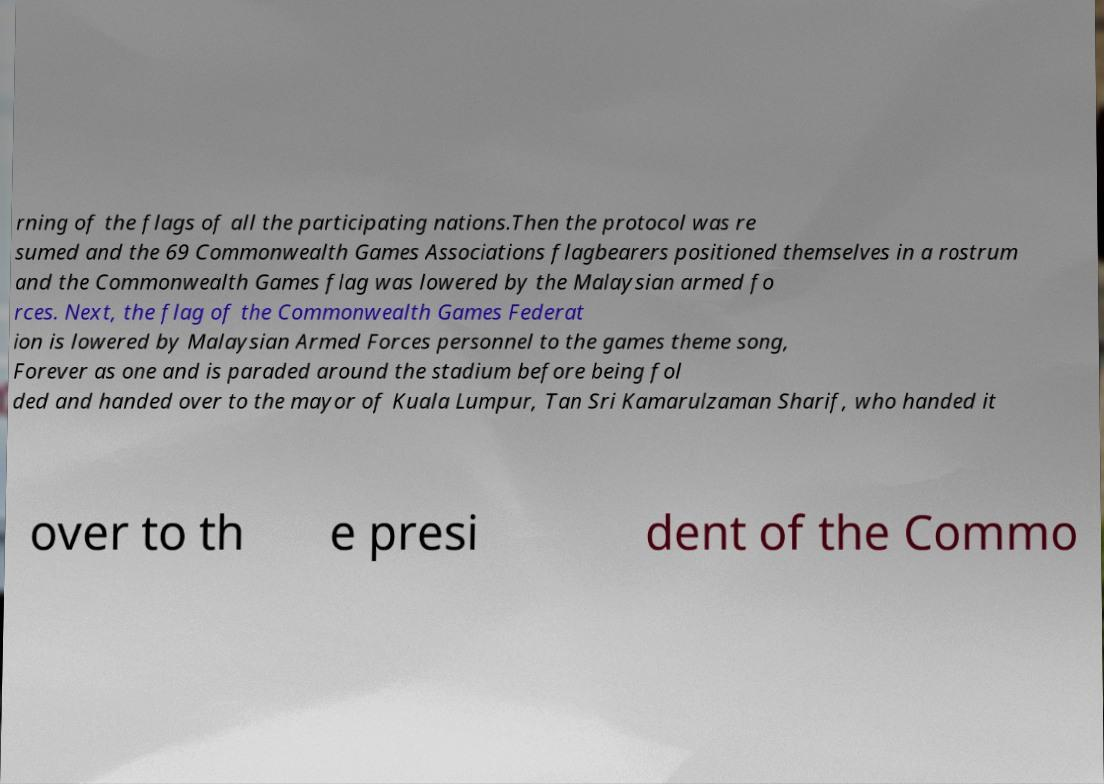Can you accurately transcribe the text from the provided image for me? rning of the flags of all the participating nations.Then the protocol was re sumed and the 69 Commonwealth Games Associations flagbearers positioned themselves in a rostrum and the Commonwealth Games flag was lowered by the Malaysian armed fo rces. Next, the flag of the Commonwealth Games Federat ion is lowered by Malaysian Armed Forces personnel to the games theme song, Forever as one and is paraded around the stadium before being fol ded and handed over to the mayor of Kuala Lumpur, Tan Sri Kamarulzaman Sharif, who handed it over to th e presi dent of the Commo 